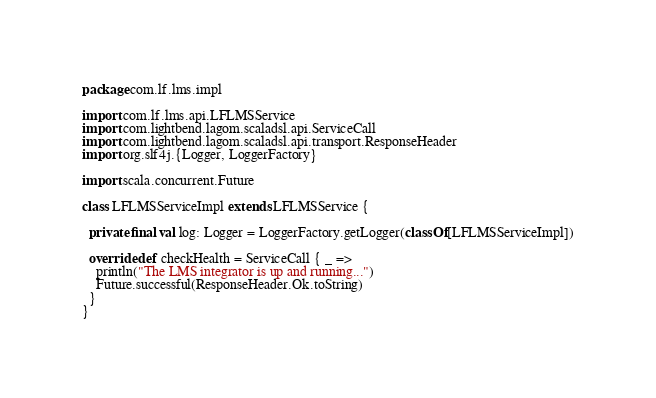Convert code to text. <code><loc_0><loc_0><loc_500><loc_500><_Scala_>package com.lf.lms.impl

import com.lf.lms.api.LFLMSService
import com.lightbend.lagom.scaladsl.api.ServiceCall
import com.lightbend.lagom.scaladsl.api.transport.ResponseHeader
import org.slf4j.{Logger, LoggerFactory}

import scala.concurrent.Future

class LFLMSServiceImpl extends LFLMSService {

  private final val log: Logger = LoggerFactory.getLogger(classOf[LFLMSServiceImpl])

  override def checkHealth = ServiceCall { _ =>
    println("The LMS integrator is up and running...")
    Future.successful(ResponseHeader.Ok.toString)
  }
}
</code> 